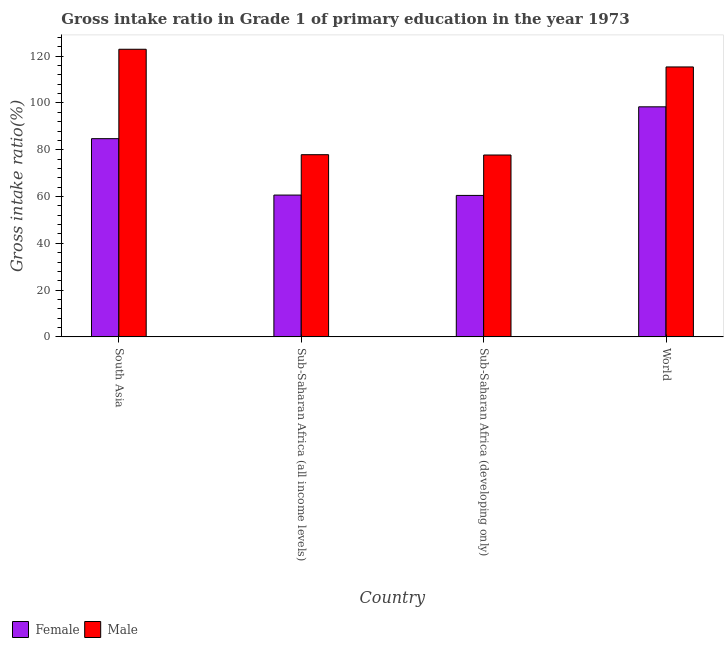How many different coloured bars are there?
Your answer should be very brief. 2. How many groups of bars are there?
Provide a succinct answer. 4. Are the number of bars per tick equal to the number of legend labels?
Your response must be concise. Yes. Are the number of bars on each tick of the X-axis equal?
Ensure brevity in your answer.  Yes. How many bars are there on the 2nd tick from the left?
Offer a terse response. 2. How many bars are there on the 2nd tick from the right?
Provide a short and direct response. 2. What is the label of the 2nd group of bars from the left?
Offer a terse response. Sub-Saharan Africa (all income levels). In how many cases, is the number of bars for a given country not equal to the number of legend labels?
Make the answer very short. 0. What is the gross intake ratio(female) in South Asia?
Give a very brief answer. 84.73. Across all countries, what is the maximum gross intake ratio(female)?
Make the answer very short. 98.34. Across all countries, what is the minimum gross intake ratio(female)?
Provide a succinct answer. 60.47. In which country was the gross intake ratio(male) maximum?
Keep it short and to the point. South Asia. In which country was the gross intake ratio(female) minimum?
Provide a short and direct response. Sub-Saharan Africa (developing only). What is the total gross intake ratio(male) in the graph?
Your answer should be very brief. 393.95. What is the difference between the gross intake ratio(male) in Sub-Saharan Africa (all income levels) and that in World?
Your answer should be very brief. -37.51. What is the difference between the gross intake ratio(female) in Sub-Saharan Africa (all income levels) and the gross intake ratio(male) in South Asia?
Keep it short and to the point. -62.33. What is the average gross intake ratio(female) per country?
Ensure brevity in your answer.  76.04. What is the difference between the gross intake ratio(male) and gross intake ratio(female) in Sub-Saharan Africa (all income levels)?
Your answer should be compact. 17.26. In how many countries, is the gross intake ratio(female) greater than 52 %?
Your answer should be very brief. 4. What is the ratio of the gross intake ratio(male) in Sub-Saharan Africa (all income levels) to that in Sub-Saharan Africa (developing only)?
Ensure brevity in your answer.  1. Is the gross intake ratio(female) in Sub-Saharan Africa (all income levels) less than that in World?
Your response must be concise. Yes. What is the difference between the highest and the second highest gross intake ratio(female)?
Your answer should be compact. 13.61. What is the difference between the highest and the lowest gross intake ratio(male)?
Offer a terse response. 45.21. What does the 1st bar from the right in Sub-Saharan Africa (developing only) represents?
Provide a short and direct response. Male. How many bars are there?
Ensure brevity in your answer.  8. Are all the bars in the graph horizontal?
Make the answer very short. No. How many countries are there in the graph?
Your response must be concise. 4. Where does the legend appear in the graph?
Your response must be concise. Bottom left. How many legend labels are there?
Give a very brief answer. 2. What is the title of the graph?
Provide a short and direct response. Gross intake ratio in Grade 1 of primary education in the year 1973. What is the label or title of the X-axis?
Offer a terse response. Country. What is the label or title of the Y-axis?
Your response must be concise. Gross intake ratio(%). What is the Gross intake ratio(%) of Female in South Asia?
Offer a terse response. 84.73. What is the Gross intake ratio(%) in Male in South Asia?
Keep it short and to the point. 122.95. What is the Gross intake ratio(%) in Female in Sub-Saharan Africa (all income levels)?
Make the answer very short. 60.62. What is the Gross intake ratio(%) in Male in Sub-Saharan Africa (all income levels)?
Ensure brevity in your answer.  77.88. What is the Gross intake ratio(%) of Female in Sub-Saharan Africa (developing only)?
Offer a very short reply. 60.47. What is the Gross intake ratio(%) of Male in Sub-Saharan Africa (developing only)?
Your response must be concise. 77.74. What is the Gross intake ratio(%) in Female in World?
Your answer should be very brief. 98.34. What is the Gross intake ratio(%) in Male in World?
Your answer should be very brief. 115.39. Across all countries, what is the maximum Gross intake ratio(%) in Female?
Keep it short and to the point. 98.34. Across all countries, what is the maximum Gross intake ratio(%) of Male?
Keep it short and to the point. 122.95. Across all countries, what is the minimum Gross intake ratio(%) in Female?
Keep it short and to the point. 60.47. Across all countries, what is the minimum Gross intake ratio(%) of Male?
Make the answer very short. 77.74. What is the total Gross intake ratio(%) in Female in the graph?
Keep it short and to the point. 304.16. What is the total Gross intake ratio(%) of Male in the graph?
Your response must be concise. 393.95. What is the difference between the Gross intake ratio(%) in Female in South Asia and that in Sub-Saharan Africa (all income levels)?
Ensure brevity in your answer.  24.11. What is the difference between the Gross intake ratio(%) of Male in South Asia and that in Sub-Saharan Africa (all income levels)?
Give a very brief answer. 45.07. What is the difference between the Gross intake ratio(%) of Female in South Asia and that in Sub-Saharan Africa (developing only)?
Provide a short and direct response. 24.26. What is the difference between the Gross intake ratio(%) in Male in South Asia and that in Sub-Saharan Africa (developing only)?
Your answer should be compact. 45.21. What is the difference between the Gross intake ratio(%) of Female in South Asia and that in World?
Offer a very short reply. -13.61. What is the difference between the Gross intake ratio(%) in Male in South Asia and that in World?
Keep it short and to the point. 7.56. What is the difference between the Gross intake ratio(%) in Female in Sub-Saharan Africa (all income levels) and that in Sub-Saharan Africa (developing only)?
Offer a terse response. 0.15. What is the difference between the Gross intake ratio(%) in Male in Sub-Saharan Africa (all income levels) and that in Sub-Saharan Africa (developing only)?
Offer a terse response. 0.14. What is the difference between the Gross intake ratio(%) in Female in Sub-Saharan Africa (all income levels) and that in World?
Make the answer very short. -37.73. What is the difference between the Gross intake ratio(%) in Male in Sub-Saharan Africa (all income levels) and that in World?
Keep it short and to the point. -37.51. What is the difference between the Gross intake ratio(%) of Female in Sub-Saharan Africa (developing only) and that in World?
Ensure brevity in your answer.  -37.87. What is the difference between the Gross intake ratio(%) in Male in Sub-Saharan Africa (developing only) and that in World?
Offer a very short reply. -37.65. What is the difference between the Gross intake ratio(%) in Female in South Asia and the Gross intake ratio(%) in Male in Sub-Saharan Africa (all income levels)?
Make the answer very short. 6.85. What is the difference between the Gross intake ratio(%) of Female in South Asia and the Gross intake ratio(%) of Male in Sub-Saharan Africa (developing only)?
Your response must be concise. 6.99. What is the difference between the Gross intake ratio(%) of Female in South Asia and the Gross intake ratio(%) of Male in World?
Provide a short and direct response. -30.66. What is the difference between the Gross intake ratio(%) in Female in Sub-Saharan Africa (all income levels) and the Gross intake ratio(%) in Male in Sub-Saharan Africa (developing only)?
Give a very brief answer. -17.12. What is the difference between the Gross intake ratio(%) in Female in Sub-Saharan Africa (all income levels) and the Gross intake ratio(%) in Male in World?
Keep it short and to the point. -54.77. What is the difference between the Gross intake ratio(%) of Female in Sub-Saharan Africa (developing only) and the Gross intake ratio(%) of Male in World?
Provide a succinct answer. -54.92. What is the average Gross intake ratio(%) in Female per country?
Provide a succinct answer. 76.04. What is the average Gross intake ratio(%) of Male per country?
Ensure brevity in your answer.  98.49. What is the difference between the Gross intake ratio(%) in Female and Gross intake ratio(%) in Male in South Asia?
Offer a terse response. -38.22. What is the difference between the Gross intake ratio(%) in Female and Gross intake ratio(%) in Male in Sub-Saharan Africa (all income levels)?
Your response must be concise. -17.26. What is the difference between the Gross intake ratio(%) of Female and Gross intake ratio(%) of Male in Sub-Saharan Africa (developing only)?
Your response must be concise. -17.27. What is the difference between the Gross intake ratio(%) of Female and Gross intake ratio(%) of Male in World?
Your answer should be compact. -17.04. What is the ratio of the Gross intake ratio(%) of Female in South Asia to that in Sub-Saharan Africa (all income levels)?
Ensure brevity in your answer.  1.4. What is the ratio of the Gross intake ratio(%) of Male in South Asia to that in Sub-Saharan Africa (all income levels)?
Your answer should be very brief. 1.58. What is the ratio of the Gross intake ratio(%) in Female in South Asia to that in Sub-Saharan Africa (developing only)?
Give a very brief answer. 1.4. What is the ratio of the Gross intake ratio(%) in Male in South Asia to that in Sub-Saharan Africa (developing only)?
Keep it short and to the point. 1.58. What is the ratio of the Gross intake ratio(%) of Female in South Asia to that in World?
Keep it short and to the point. 0.86. What is the ratio of the Gross intake ratio(%) in Male in South Asia to that in World?
Offer a terse response. 1.07. What is the ratio of the Gross intake ratio(%) in Female in Sub-Saharan Africa (all income levels) to that in Sub-Saharan Africa (developing only)?
Your answer should be compact. 1. What is the ratio of the Gross intake ratio(%) of Male in Sub-Saharan Africa (all income levels) to that in Sub-Saharan Africa (developing only)?
Your response must be concise. 1. What is the ratio of the Gross intake ratio(%) in Female in Sub-Saharan Africa (all income levels) to that in World?
Ensure brevity in your answer.  0.62. What is the ratio of the Gross intake ratio(%) in Male in Sub-Saharan Africa (all income levels) to that in World?
Offer a very short reply. 0.67. What is the ratio of the Gross intake ratio(%) in Female in Sub-Saharan Africa (developing only) to that in World?
Your answer should be very brief. 0.61. What is the ratio of the Gross intake ratio(%) in Male in Sub-Saharan Africa (developing only) to that in World?
Your answer should be compact. 0.67. What is the difference between the highest and the second highest Gross intake ratio(%) in Female?
Give a very brief answer. 13.61. What is the difference between the highest and the second highest Gross intake ratio(%) of Male?
Give a very brief answer. 7.56. What is the difference between the highest and the lowest Gross intake ratio(%) of Female?
Make the answer very short. 37.87. What is the difference between the highest and the lowest Gross intake ratio(%) in Male?
Your answer should be very brief. 45.21. 